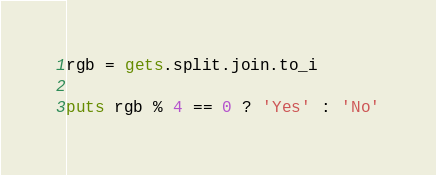<code> <loc_0><loc_0><loc_500><loc_500><_Ruby_>rgb = gets.split.join.to_i
 
puts rgb % 4 == 0 ? 'Yes' : 'No'</code> 